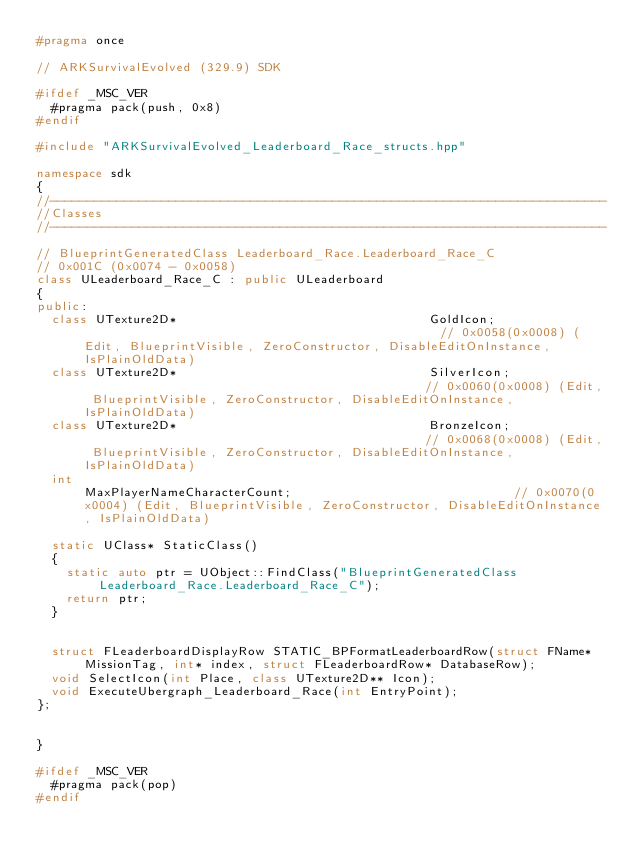Convert code to text. <code><loc_0><loc_0><loc_500><loc_500><_C++_>#pragma once

// ARKSurvivalEvolved (329.9) SDK

#ifdef _MSC_VER
	#pragma pack(push, 0x8)
#endif

#include "ARKSurvivalEvolved_Leaderboard_Race_structs.hpp"

namespace sdk
{
//---------------------------------------------------------------------------
//Classes
//---------------------------------------------------------------------------

// BlueprintGeneratedClass Leaderboard_Race.Leaderboard_Race_C
// 0x001C (0x0074 - 0x0058)
class ULeaderboard_Race_C : public ULeaderboard
{
public:
	class UTexture2D*                                  GoldIcon;                                                 // 0x0058(0x0008) (Edit, BlueprintVisible, ZeroConstructor, DisableEditOnInstance, IsPlainOldData)
	class UTexture2D*                                  SilverIcon;                                               // 0x0060(0x0008) (Edit, BlueprintVisible, ZeroConstructor, DisableEditOnInstance, IsPlainOldData)
	class UTexture2D*                                  BronzeIcon;                                               // 0x0068(0x0008) (Edit, BlueprintVisible, ZeroConstructor, DisableEditOnInstance, IsPlainOldData)
	int                                                MaxPlayerNameCharacterCount;                              // 0x0070(0x0004) (Edit, BlueprintVisible, ZeroConstructor, DisableEditOnInstance, IsPlainOldData)

	static UClass* StaticClass()
	{
		static auto ptr = UObject::FindClass("BlueprintGeneratedClass Leaderboard_Race.Leaderboard_Race_C");
		return ptr;
	}


	struct FLeaderboardDisplayRow STATIC_BPFormatLeaderboardRow(struct FName* MissionTag, int* index, struct FLeaderboardRow* DatabaseRow);
	void SelectIcon(int Place, class UTexture2D** Icon);
	void ExecuteUbergraph_Leaderboard_Race(int EntryPoint);
};


}

#ifdef _MSC_VER
	#pragma pack(pop)
#endif
</code> 